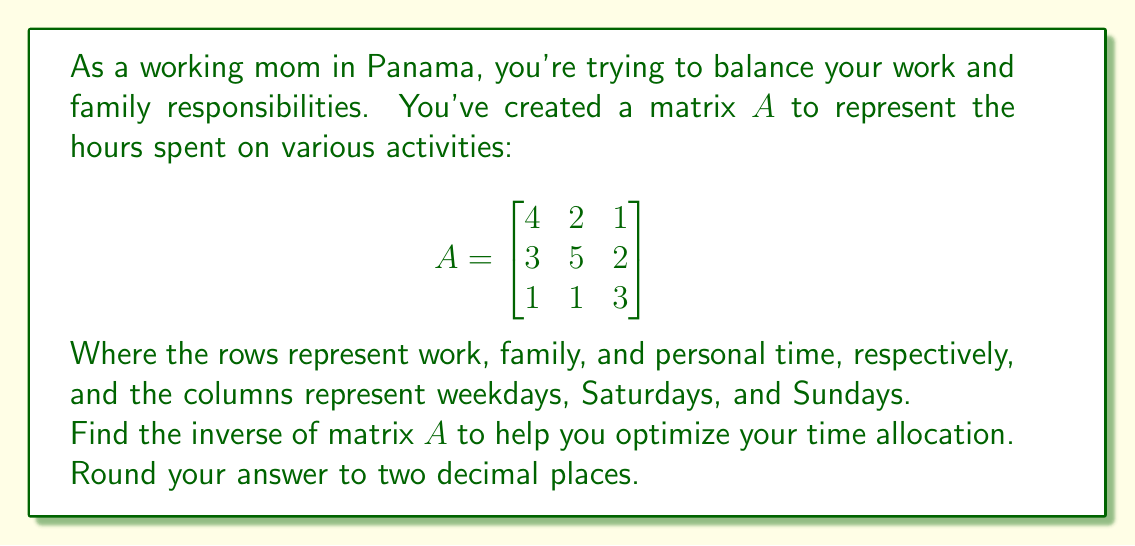Show me your answer to this math problem. To find the inverse of matrix $A$, we'll follow these steps:

1. Calculate the determinant of $A$
2. Find the adjugate matrix of $A$
3. Divide the adjugate matrix by the determinant

Step 1: Calculate the determinant of $A$

$$\det(A) = 4(15-2) - 2(9-2) + 1(15-3) = 52 - 14 + 12 = 50$$

Step 2: Find the adjugate matrix of $A$

First, we need to find the cofactor matrix:

$$C_{11} = (15-2) = 13$$
$$C_{12} = -(9-2) = -7$$
$$C_{13} = (15-3) = 12$$
$$C_{21} = -(10-1) = -9$$
$$C_{22} = (12-1) = 11$$
$$C_{23} = -(8-3) = -5$$
$$C_{31} = (10-4) = 6$$
$$C_{32} = -(12-6) = -6$$
$$C_{33} = (20-6) = 14$$

The cofactor matrix is:

$$C = \begin{bmatrix}
13 & -7 & 12 \\
-9 & 11 & -5 \\
6 & -6 & 14
\end{bmatrix}$$

The adjugate matrix is the transpose of the cofactor matrix:

$$\text{adj}(A) = C^T = \begin{bmatrix}
13 & -9 & 6 \\
-7 & 11 & -6 \\
12 & -5 & 14
\end{bmatrix}$$

Step 3: Divide the adjugate matrix by the determinant

$$A^{-1} = \frac{1}{\det(A)} \cdot \text{adj}(A) = \frac{1}{50} \cdot \begin{bmatrix}
13 & -9 & 6 \\
-7 & 11 & -6 \\
12 & -5 & 14
\end{bmatrix}$$

Simplifying and rounding to two decimal places:

$$A^{-1} = \begin{bmatrix}
0.26 & -0.18 & 0.12 \\
-0.14 & 0.22 & -0.12 \\
0.24 & -0.10 & 0.28
\end{bmatrix}$$
Answer: $$A^{-1} = \begin{bmatrix}
0.26 & -0.18 & 0.12 \\
-0.14 & 0.22 & -0.12 \\
0.24 & -0.10 & 0.28
\end{bmatrix}$$ 